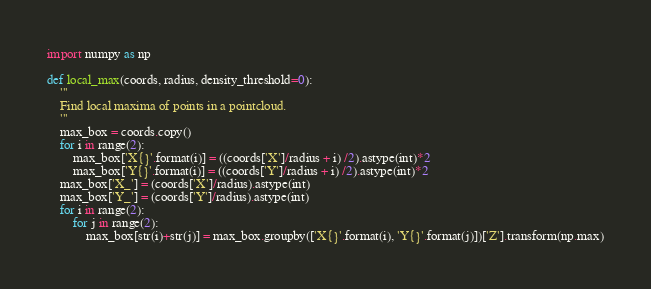<code> <loc_0><loc_0><loc_500><loc_500><_Python_>import numpy as np

def local_max(coords, radius, density_threshold=0):
    '''
    Find local maxima of points in a pointcloud.
    '''
    max_box = coords.copy()
    for i in range(2):
        max_box['X{}'.format(i)] = ((coords['X']/radius + i) /2).astype(int)*2
        max_box['Y{}'.format(i)] = ((coords['Y']/radius + i) /2).astype(int)*2
    max_box['X_'] = (coords['X']/radius).astype(int)
    max_box['Y_'] = (coords['Y']/radius).astype(int)
    for i in range(2):
        for j in range(2):
            max_box[str(i)+str(j)] = max_box.groupby(['X{}'.format(i), 'Y{}'.format(j)])['Z'].transform(np.max)</code> 